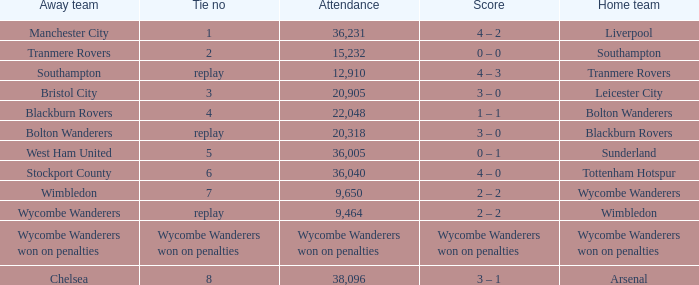What was the attendance for the game where the away team was Stockport County? 36040.0. 